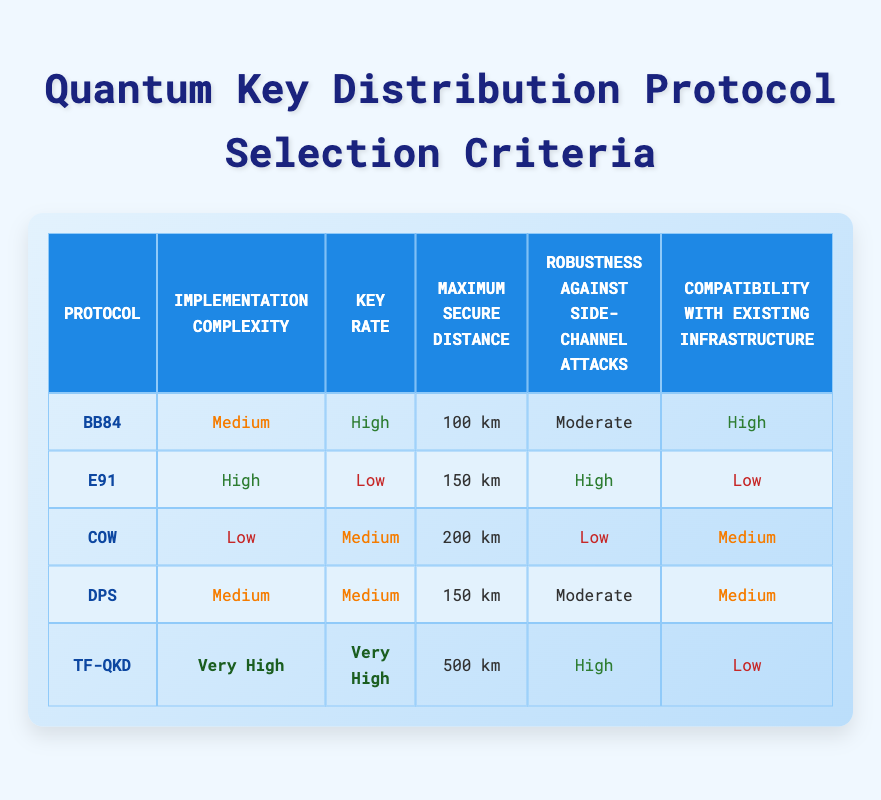What is the maximum secure distance for the TF-QKD protocol? The TF-QKD protocol has a maximum secure distance listed in the table, which is directly referenced. Looking at the corresponding row, it states that the maximum secure distance is 500 km.
Answer: 500 km Which protocol has the highest key rate? In the key rate column, we look for the highest value among the protocols. The TF-QKD protocol has a very high key rate, which is higher than all other protocols listed.
Answer: TF-QKD Is the compatibility of the E91 protocol high? By checking the compatibility column for the E91 protocol, we see that it is labeled as low. Therefore, the answer to whether its compatibility is high is false.
Answer: No What is the average implementation complexity rating for all protocols? The implementation complexities are Medium, High, Low, Medium, and Very High. If we assign numerical values (Low=1, Medium=2, High=3, Very High=4), the sum is (2 + 3 + 1 + 2 + 4) = 12. There are 5 protocols, so the average complexity is 12/5 = 2.4, which corresponds to Medium.
Answer: Medium Which protocol provides low robustness against side-channel attacks and what is its maximum secure distance? First, we identify protocols with low robustness. The COW protocol is labeled as low for robustness. In the same row, the corresponding maximum secure distance is 200 km.
Answer: COW, 200 km How many protocols have a high key rate and maximum secure distance greater than 100 km? We inspect the key rate column and find that both BB84 and TF-QKD protocols have a high key rate. Then, we verify their maximum secure distances: BB84 (100 km) does not qualify, but TF-QKD (500 km) does. Thus, only TF-QKD counts, making the total 1.
Answer: 1 Is the implementation complexity for COW protocol lower than that of the BB84 protocol? Comparing the implementation complexity values, COW is marked as low while BB84 is medium. Since low is lower than medium, the statement is true.
Answer: Yes What is the protocol with the lowest compatibility rating? We check the compatibility ratings where E91 is listed as low, and TF-QKD also has a low rating. Comparing both, we find that E91 is indeed the lowest stated as low.
Answer: E91 and TF-QKD 